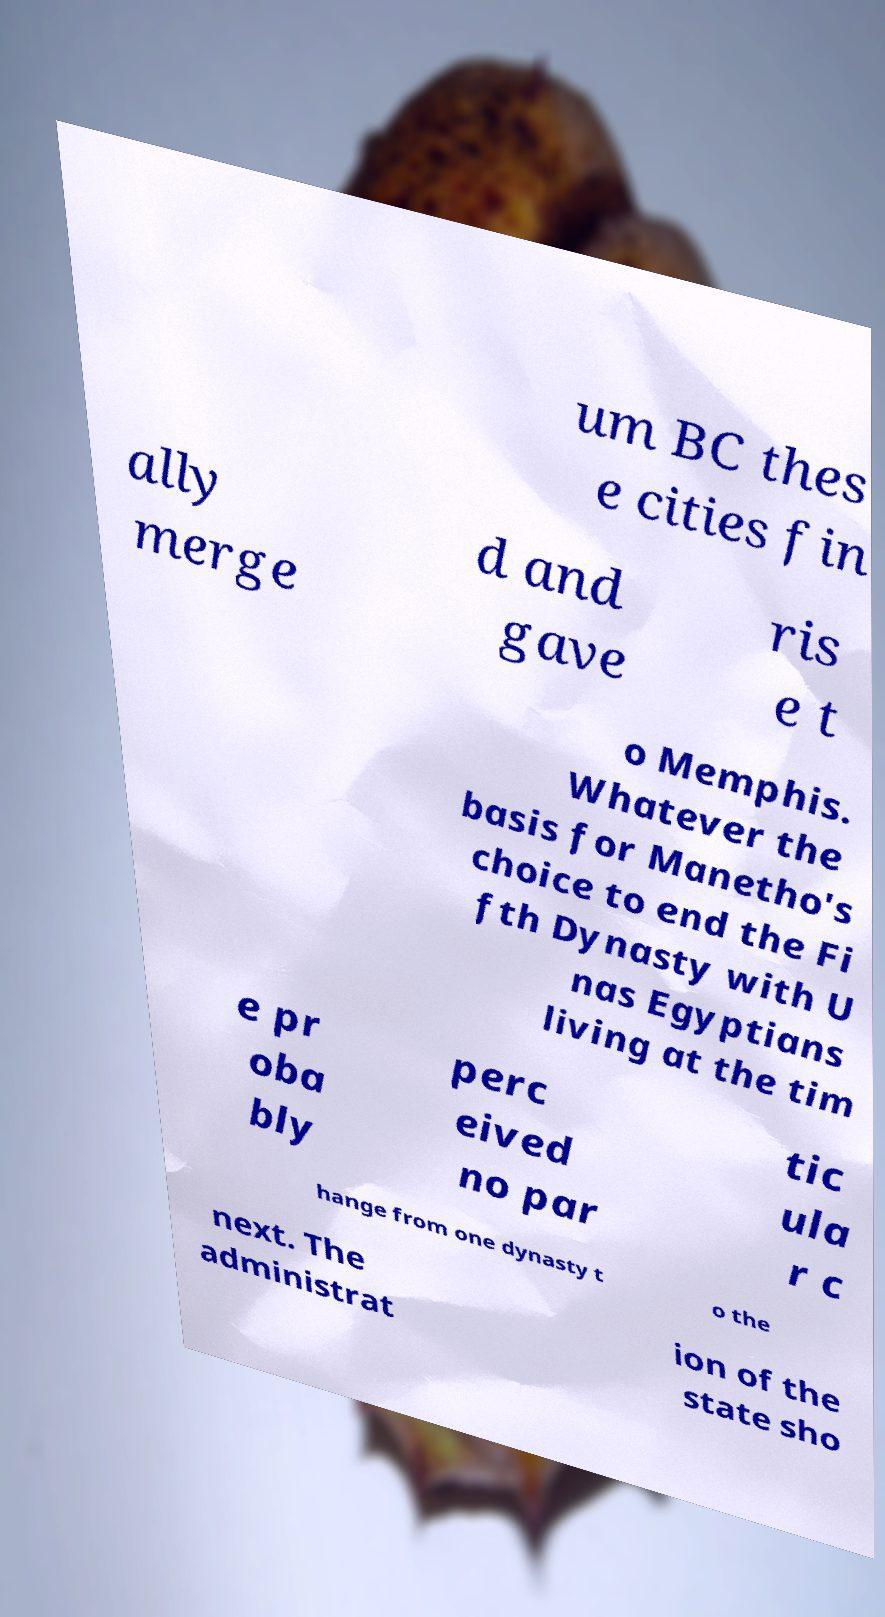I need the written content from this picture converted into text. Can you do that? um BC thes e cities fin ally merge d and gave ris e t o Memphis. Whatever the basis for Manetho's choice to end the Fi fth Dynasty with U nas Egyptians living at the tim e pr oba bly perc eived no par tic ula r c hange from one dynasty t o the next. The administrat ion of the state sho 